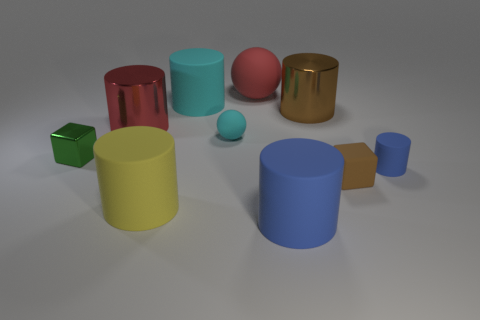What is the approximate size ratio between the red rubber thing and the blue cylinder? The red object and the blue cylinder appear to be of similar height, but the cylinder is wider, suggesting a size ratio where the cylinder has greater volume. 